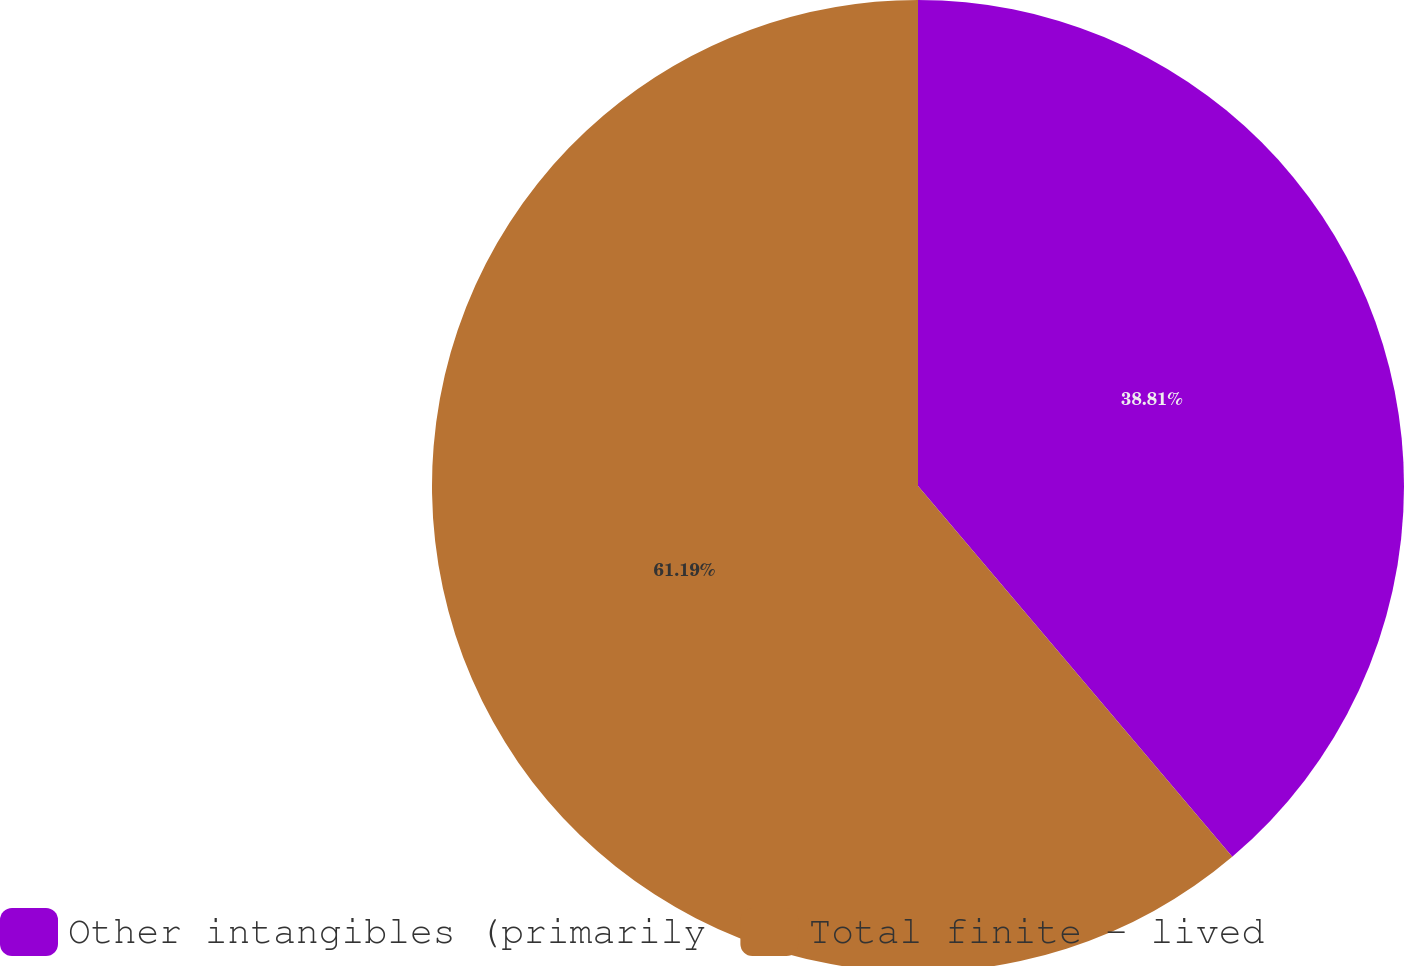<chart> <loc_0><loc_0><loc_500><loc_500><pie_chart><fcel>Other intangibles (primarily<fcel>Total finite - lived<nl><fcel>38.81%<fcel>61.19%<nl></chart> 